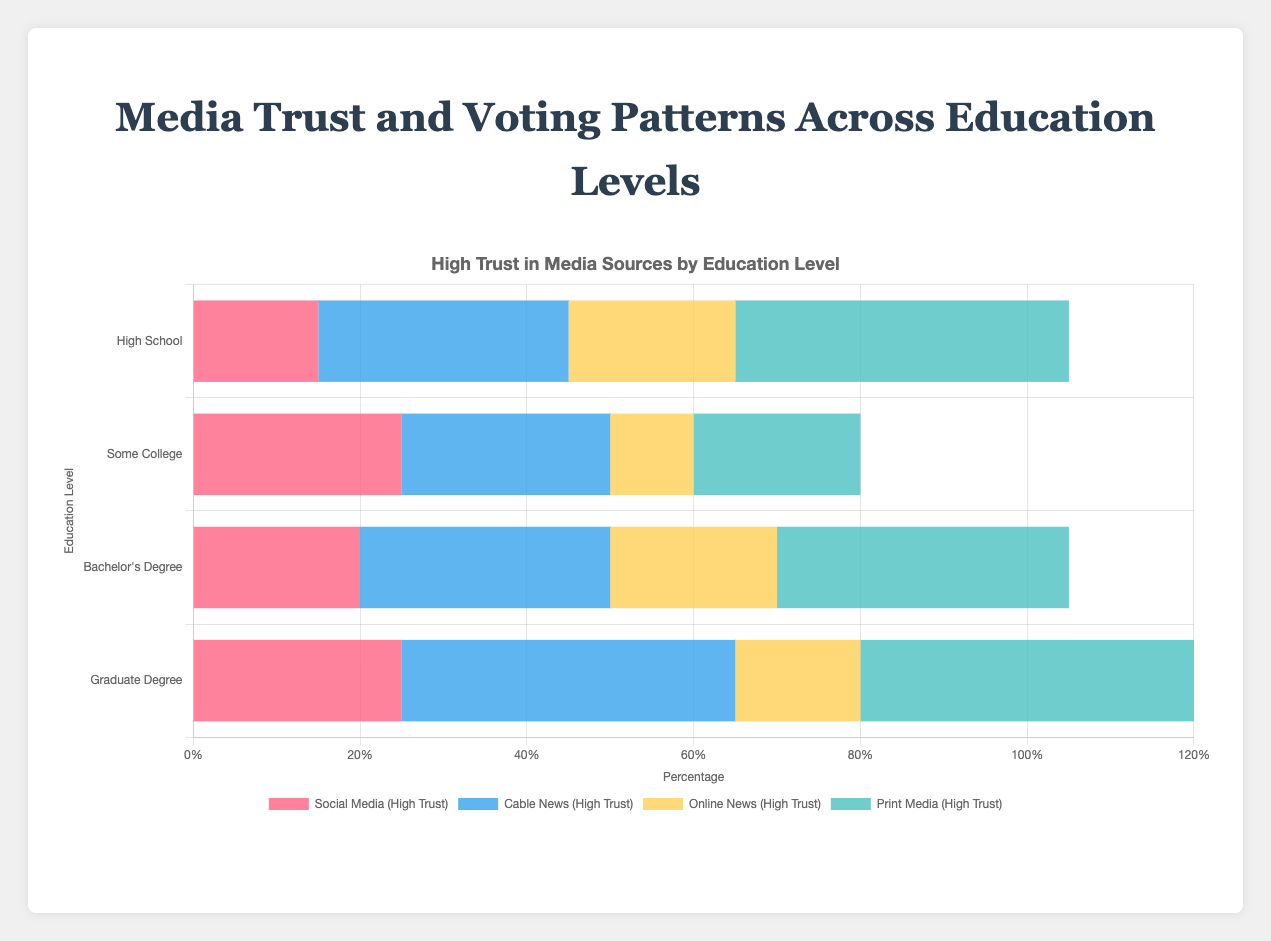Which media source has the highest trust level among people with a high school education? For people with a high school education, Print Media has the highest trust level at 40%. This is evident from the bar corresponding to high trust in Print Media being the tallest among all sources for this group.
Answer: Print Media How does the trust in Social Media compare between those with a Bachelor’s Degree and a Graduate Degree? People with a Bachelor's Degree have 20% high trust in Social Media, whereas those with a Graduate Degree have 25% high trust, indicating that trust in Social Media increases slightly with higher education levels.
Answer: Graduate Degree has higher trust What is the average high trust level for Cable News across all education levels? The high trust values for Cable News are 30%, 25%, 30%, and 40% for High School, Some College, Bachelor's Degree, and Graduate Degree respectively. Averaging these: (30 + 25 + 30 + 40) / 4 = 31.25%
Answer: 31.25% Among people with Some College education, which media source has the lowest high trust level? For Some College education, Online News has the lowest high trust level at 10%, visible by the shortest bar among those representing high trust.
Answer: Online News Which education level shows the most trust in Print Media, and what percentage does it show? People with a Graduate Degree show the most trust in Print Media with a high trust level of 40%. This is seen by the tallest bar for Print Media in the Graduate Degree category.
Answer: Graduate Degree, 40% What is the difference in high trust levels in Cable News between people with Some College education and High School education? People with Some College education have a 25% high trust in Cable News, whereas those with a High School education have 30% high trust. The difference is 30% - 25% = 5%.
Answer: 5% Visually, which education level seems to have the most varied trust across different media sources? The High School level shows varied trust across media sources, evident from the significantly different bar heights for each source. For example, high trust varies from 15% for Social Media to 40% for Print Media.
Answer: High School Does the high trust in Online News differ significantly between education levels? No, the high trust in Online News is fairly consistent across education levels, always around 20%. Bars for Online News in the high trust category are similar in height across education levels.
Answer: No How does the distribution of trust in media sources for people with a High School education compare to those with a Graduate Degree? For High School education, the highest trust is in Print Media (40%), while for Graduate Degrees, Print Media and Cable News both show high trust levels (40%). Social Media trust is higher at lower education levels. This indicates a trend where trust diversifies with higher education.
Answer: Trust is more varied with higher education 